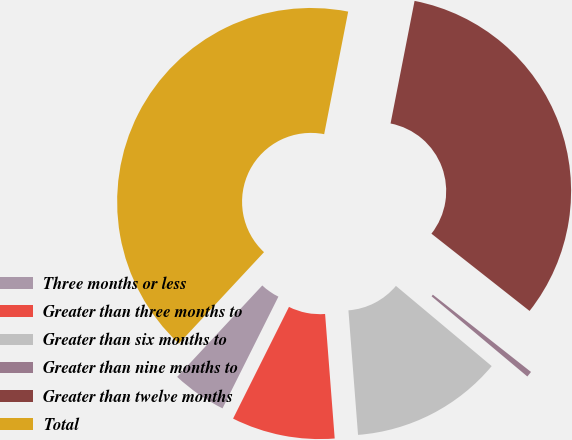<chart> <loc_0><loc_0><loc_500><loc_500><pie_chart><fcel>Three months or less<fcel>Greater than three months to<fcel>Greater than six months to<fcel>Greater than nine months to<fcel>Greater than twelve months<fcel>Total<nl><fcel>4.55%<fcel>8.61%<fcel>12.68%<fcel>0.48%<fcel>32.54%<fcel>41.15%<nl></chart> 